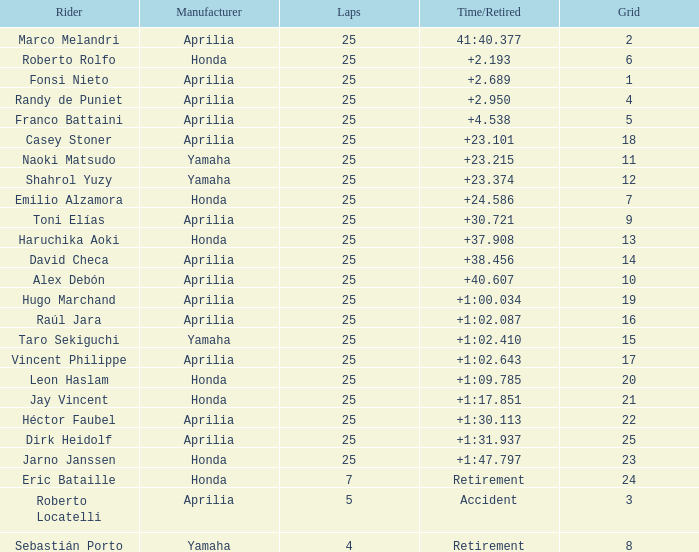From which manufacturer are there incidents involving time-based or retired accidents? Aprilia. 